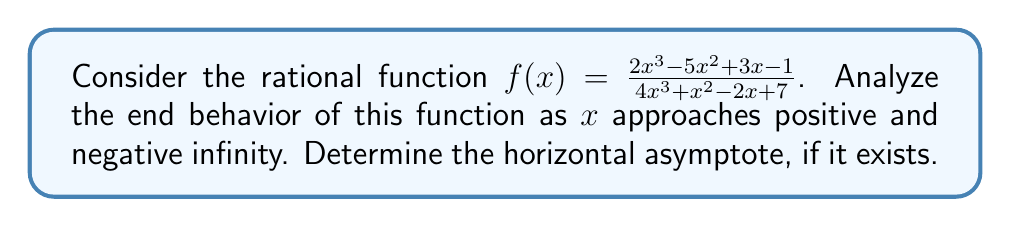Provide a solution to this math problem. To analyze the end behavior of a rational function, we need to compare the degrees of the numerator and denominator polynomials.

1. Identify the degrees:
   Numerator: $2x^3 - 5x^2 + 3x - 1$ has degree 3
   Denominator: $4x^3 + x^2 - 2x + 7$ has degree 3

2. Compare the degrees:
   Since both numerator and denominator have the same degree (3), the function will have a horizontal asymptote.

3. Find the horizontal asymptote:
   The horizontal asymptote is determined by the ratio of the leading coefficients of the numerator and denominator.

   Leading coefficient of numerator: 2
   Leading coefficient of denominator: 4

   Horizontal asymptote: $y = \frac{2}{4} = \frac{1}{2}$

4. Analyze end behavior:
   As $x \to \pm\infty$, the function will approach the horizontal asymptote $y = \frac{1}{2}$.

   For very large positive or negative x-values, the lower-degree terms become insignificant compared to the highest-degree terms. Thus, the function behaves like:

   $$f(x) \approx \frac{2x^3}{4x^3} = \frac{1}{2}$$

   This means that as $x$ approaches positive or negative infinity, the function values will get arbitrarily close to $\frac{1}{2}$.
Answer: As $x \to \pm\infty$, $f(x) \to \frac{1}{2}$. The function has a horizontal asymptote at $y = \frac{1}{2}$. 